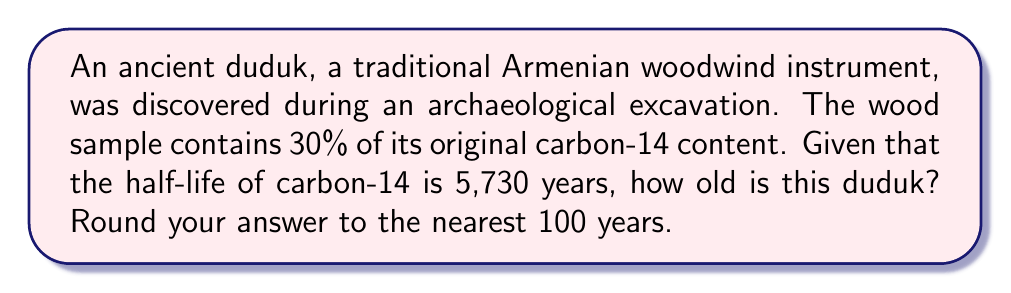Could you help me with this problem? Let's approach this step-by-step using the exponential decay formula and logarithms:

1) The exponential decay formula is:
   $$N(t) = N_0 \cdot (0.5)^{t/t_{1/2}}$$
   where $N(t)$ is the amount remaining after time $t$, $N_0$ is the initial amount, and $t_{1/2}$ is the half-life.

2) We know that:
   - $N(t)/N_0 = 0.30$ (30% remaining)
   - $t_{1/2} = 5,730$ years

3) Substituting into the formula:
   $$0.30 = (0.5)^{t/5730}$$

4) Taking the natural logarithm of both sides:
   $$\ln(0.30) = \ln((0.5)^{t/5730})$$

5) Using the logarithm property $\ln(a^b) = b\ln(a)$:
   $$\ln(0.30) = \frac{t}{5730} \ln(0.5)$$

6) Solving for $t$:
   $$t = \frac{5730 \ln(0.30)}{\ln(0.5)}$$

7) Calculate:
   $$t = \frac{5730 \cdot (-1.2039)}{-0.6931} \approx 9,954.8$$

8) Rounding to the nearest 100 years:
   $$t \approx 10,000 \text{ years}$$
Answer: 10,000 years 